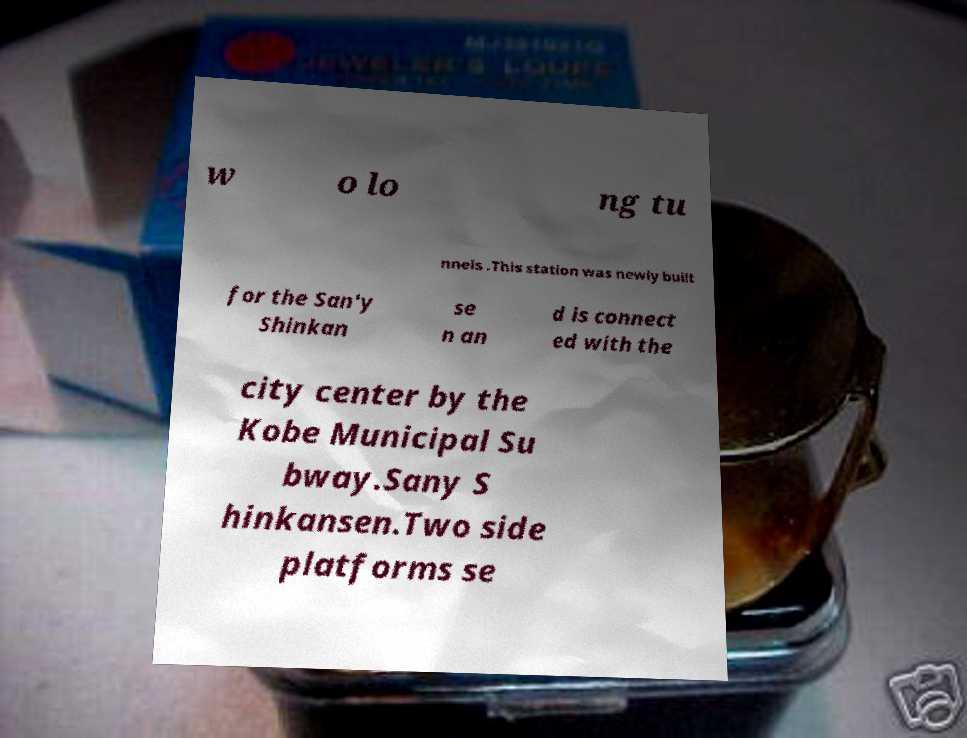Can you read and provide the text displayed in the image?This photo seems to have some interesting text. Can you extract and type it out for me? w o lo ng tu nnels .This station was newly built for the San'y Shinkan se n an d is connect ed with the city center by the Kobe Municipal Su bway.Sany S hinkansen.Two side platforms se 